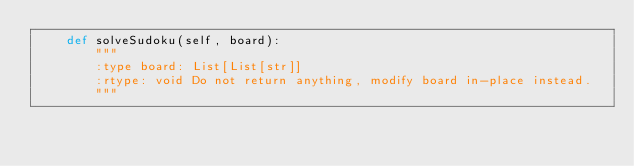Convert code to text. <code><loc_0><loc_0><loc_500><loc_500><_Python_>    def solveSudoku(self, board):
        """
        :type board: List[List[str]]
        :rtype: void Do not return anything, modify board in-place instead.
        """</code> 